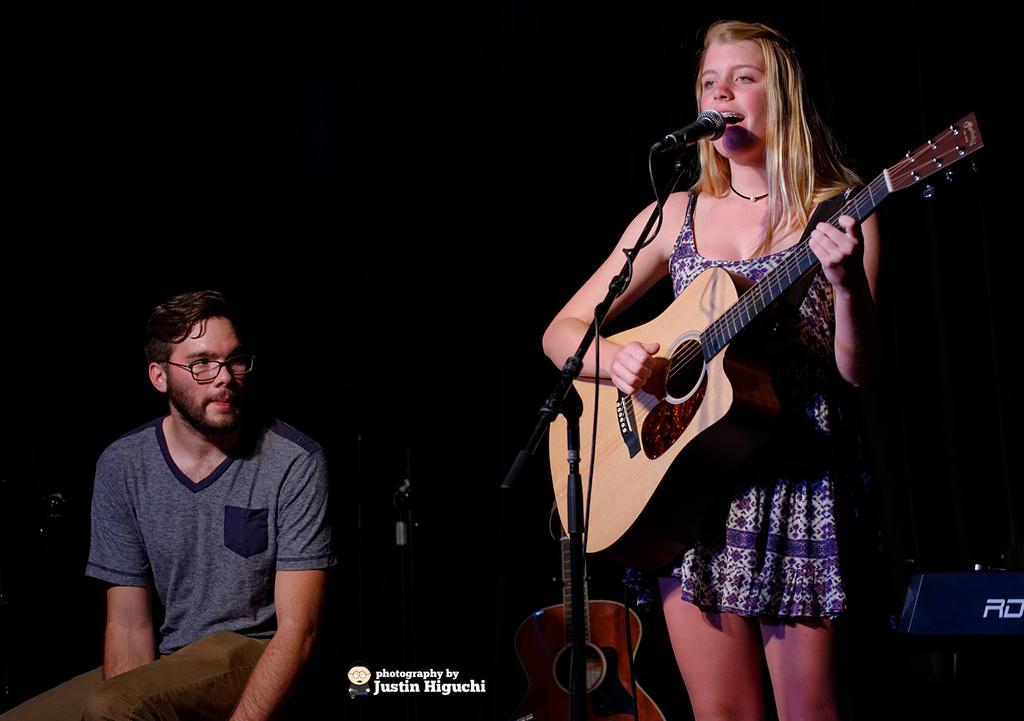In one or two sentences, can you explain what this image depicts? Here we can see a woman playing a guitar and singing a song with a microphone present in front of her and beside her we can see a man sitting and there are guitars present here and there 